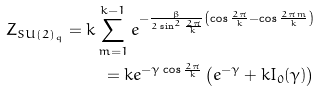<formula> <loc_0><loc_0><loc_500><loc_500>Z _ { S U ( 2 ) _ { q } } = k \sum _ { m = 1 } ^ { k - 1 } e ^ { - { \frac { \beta } { 2 \sin ^ { 2 } { \frac { 2 \pi } { k } } } } \left ( \cos { \frac { 2 \pi } { k } } - \cos { \frac { 2 \pi m } { k } } \right ) } \\ = k e ^ { - \gamma \cos \frac { 2 \pi } { k } } \left ( e ^ { - \gamma } + k I _ { 0 } ( \gamma ) \right )</formula> 